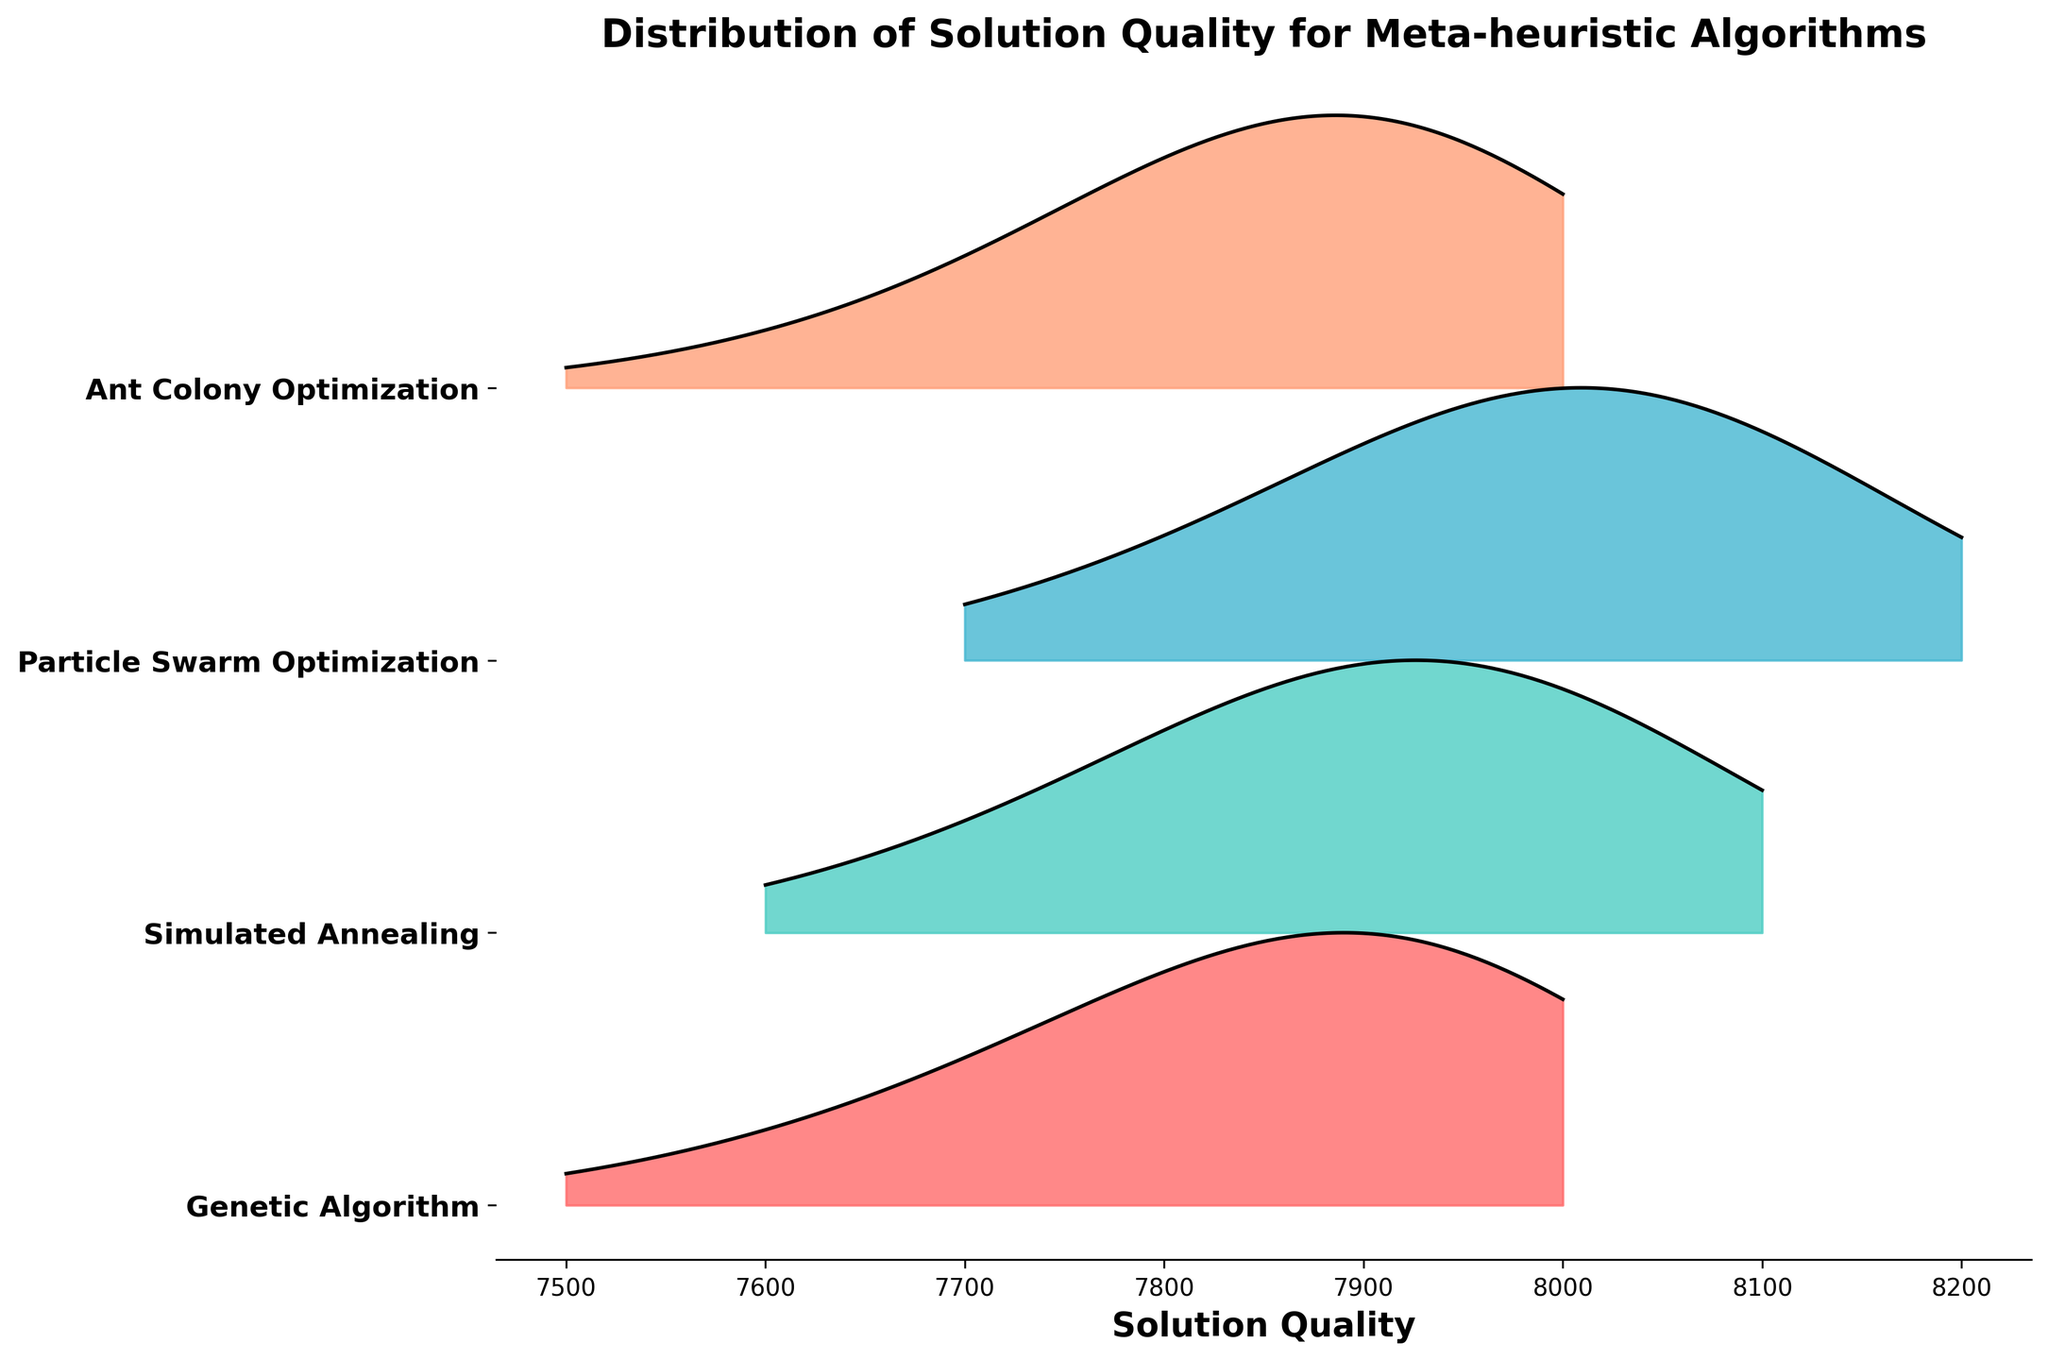What is the title of the plot? The title of the plot is written at the top of the figure. It gives an overview of what the visual is about.
Answer: Distribution of Solution Quality for Meta-heuristic Algorithms What does the x-axis represent in the plot? The x-axis is labeled, and it defines what measurement or data point is displayed horizontally.
Answer: Solution Quality How many different algorithms are compared in the plot? We can count the number of different labels on the y-axis, which represent the different algorithms.
Answer: 4 Which algorithm seems to have the highest peak in its solution quality distribution? We need to observe each ridge and identify which one has the highest peak. Peaks are where the curve reaches maximum height.
Answer: Ant Colony Optimization Which algorithm shows the broadest distribution of solution quality? The broadest distribution can be seen where the curve spans the widest range on the x-axis.
Answer: Particle Swarm Optimization Which algorithm has the most frequent solution quality around 7900? Locate where solution quality equals approximately 7900 on the x-axis and check which algorithm's ridge has the highest peak in that region.
Answer: Ant Colony Optimization Is the solution quality distribution for Genetic Algorithm skewed towards higher or lower values? Examine the shape and direction of the ridge for Genetic Algorithm. If more area is concentrated towards the right, it’s skewed toward higher values.
Answer: Higher values Between Simulated Annealing and Particle Swarm Optimization, which has a higher frequency at a solution quality of 8000? Compare the heights of the ridges for Simulated Annealing and Particle Swarm Optimization at the point where solution quality is 8000.
Answer: Particle Swarm Optimization Is there any algorithm that shows a notable distribution peak at a solution quality of 8100? Look across the ridges at the solution quality of 8100 to see if any algorithm has a significant peak.
Answer: Simulated Annealing Which algorithm has its frequency distribution peak furthest to the right? The furthest peak to the right can be identified by finding the peak at the highest solution quality among the algorithms.
Answer: Particle Swarm Optimization 